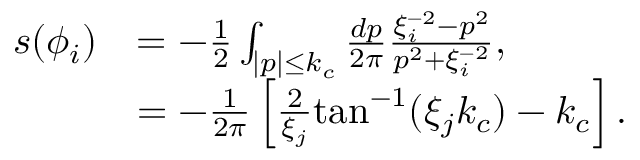<formula> <loc_0><loc_0><loc_500><loc_500>\begin{array} { r l } { s ( \phi _ { i } ) } & { = - \frac { 1 } { 2 } \int _ { | p | \leq k _ { c } } \frac { d p } { 2 \pi } \frac { \xi _ { i } ^ { - 2 } - p ^ { 2 } } { p ^ { 2 } + \xi _ { i } ^ { - 2 } } , } \\ & { = - \frac { 1 } { 2 \pi } \left [ \frac { 2 } { \xi _ { j } } t a n ^ { - 1 } ( \xi _ { j } k _ { c } ) - k _ { c } \right ] . } \end{array}</formula> 